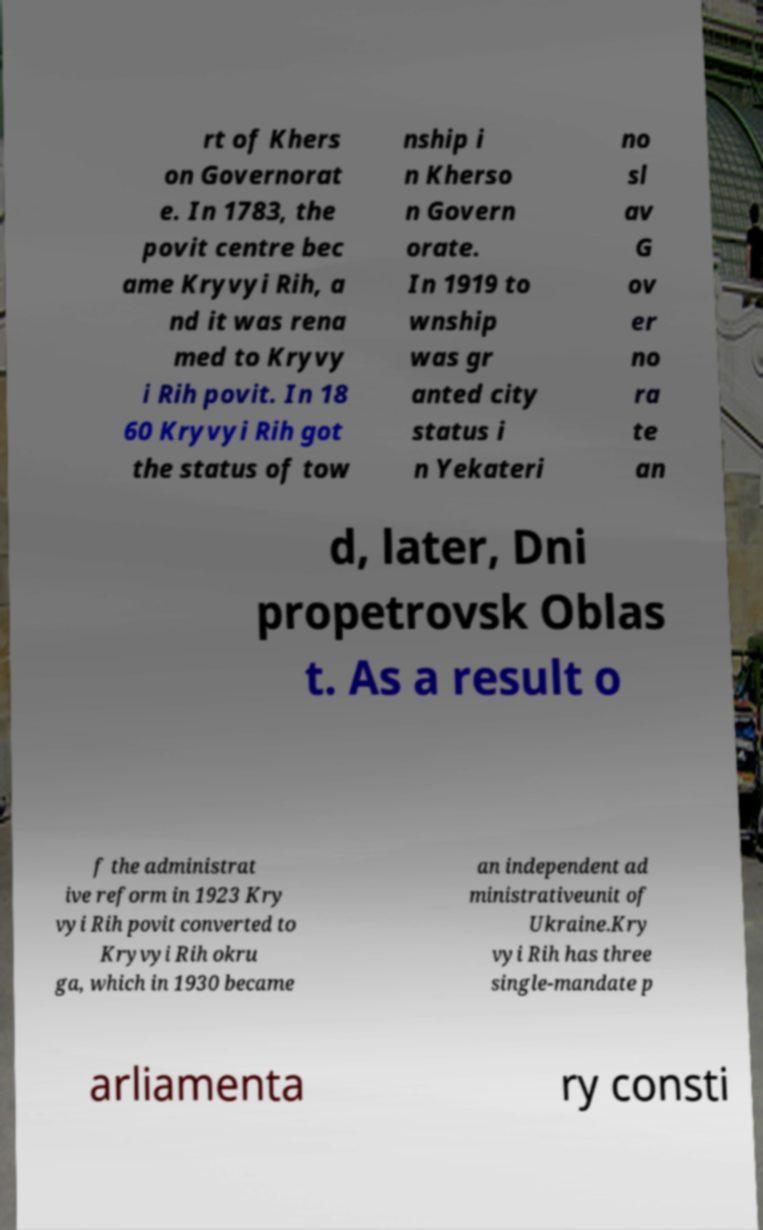For documentation purposes, I need the text within this image transcribed. Could you provide that? rt of Khers on Governorat e. In 1783, the povit centre bec ame Kryvyi Rih, a nd it was rena med to Kryvy i Rih povit. In 18 60 Kryvyi Rih got the status of tow nship i n Kherso n Govern orate. In 1919 to wnship was gr anted city status i n Yekateri no sl av G ov er no ra te an d, later, Dni propetrovsk Oblas t. As a result o f the administrat ive reform in 1923 Kry vyi Rih povit converted to Kryvyi Rih okru ga, which in 1930 became an independent ad ministrativeunit of Ukraine.Kry vyi Rih has three single-mandate p arliamenta ry consti 